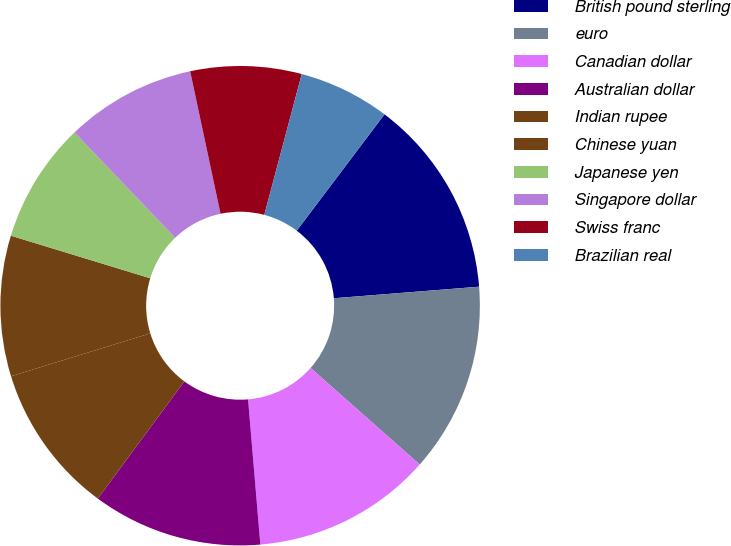<chart> <loc_0><loc_0><loc_500><loc_500><pie_chart><fcel>British pound sterling<fcel>euro<fcel>Canadian dollar<fcel>Australian dollar<fcel>Indian rupee<fcel>Chinese yuan<fcel>Japanese yen<fcel>Singapore dollar<fcel>Swiss franc<fcel>Brazilian real<nl><fcel>13.45%<fcel>12.79%<fcel>12.13%<fcel>11.46%<fcel>10.13%<fcel>9.47%<fcel>8.14%<fcel>8.8%<fcel>7.48%<fcel>6.15%<nl></chart> 